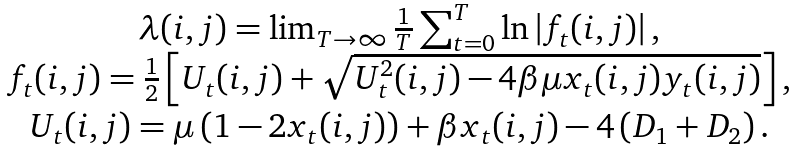<formula> <loc_0><loc_0><loc_500><loc_500>\begin{array} { c } \lambda ( i , j ) = \lim _ { T \rightarrow \infty } \frac { 1 } { T } \sum _ { t = 0 } ^ { T } \ln \left | f _ { t } ( i , j ) \right | , \\ f _ { t } ( i , j ) = \frac { 1 } { 2 } \left [ U _ { t } ( i , j ) + \sqrt { U _ { t } ^ { 2 } ( i , j ) - 4 \beta \mu x _ { t } ( i , j ) y _ { t } ( i , j ) } \right ] , \\ U _ { t } ( i , j ) = \mu \left ( 1 - 2 x _ { t } ( i , j ) \right ) + \beta x _ { t } ( i , j ) - 4 \left ( D _ { 1 } + D _ { 2 } \right ) . \end{array}</formula> 